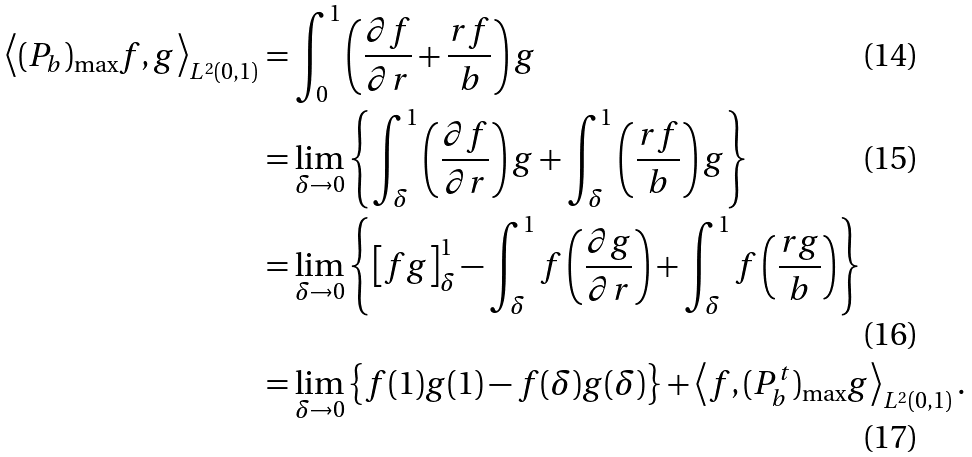Convert formula to latex. <formula><loc_0><loc_0><loc_500><loc_500>\left \langle ( P _ { b } ) _ { \max } f , g \right \rangle _ { L ^ { 2 } ( 0 , 1 ) } & = \int _ { 0 } ^ { 1 } \left ( \frac { \partial f } { \partial r } + \frac { r f } { b } \right ) g \\ & = \lim _ { \delta \rightarrow 0 } \left \{ \int _ { \delta } ^ { 1 } \left ( \frac { \partial f } { \partial r } \right ) g + \int _ { \delta } ^ { 1 } \left ( \frac { r f } { b } \right ) g \right \} \\ & = \lim _ { \delta \rightarrow 0 } \left \{ \left [ f g \right ] _ { \delta } ^ { 1 } - \int _ { \delta } ^ { 1 } f \left ( \frac { \partial g } { \partial r } \right ) + \int _ { \delta } ^ { 1 } f \left ( \frac { r g } { b } \right ) \right \} \\ & = \lim _ { \delta \rightarrow 0 } \left \{ f ( 1 ) g ( 1 ) - f ( \delta ) g ( \delta ) \right \} + \left \langle f , ( P _ { b } ^ { t } ) _ { \max } g \right \rangle _ { L ^ { 2 } ( 0 , 1 ) } .</formula> 